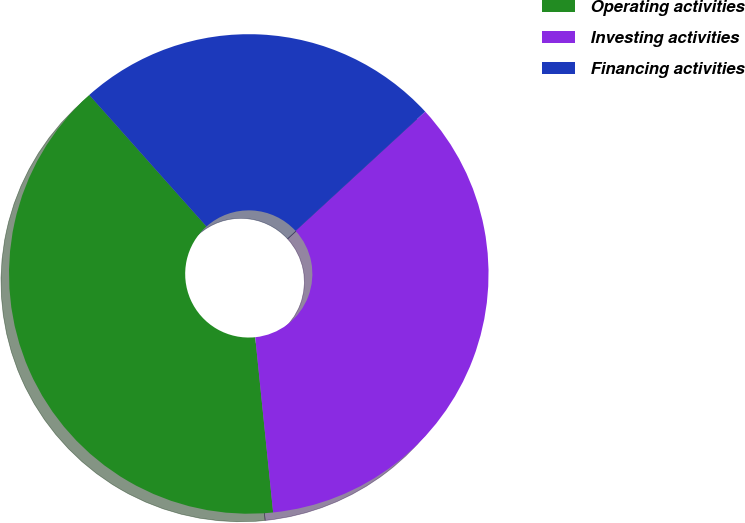Convert chart. <chart><loc_0><loc_0><loc_500><loc_500><pie_chart><fcel>Operating activities<fcel>Investing activities<fcel>Financing activities<nl><fcel>40.04%<fcel>35.22%<fcel>24.75%<nl></chart> 